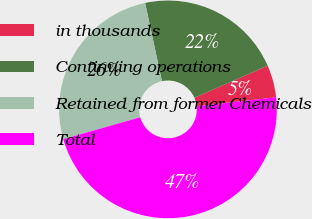<chart> <loc_0><loc_0><loc_500><loc_500><pie_chart><fcel>in thousands<fcel>Continuing operations<fcel>Retained from former Chemicals<fcel>Total<nl><fcel>4.81%<fcel>21.79%<fcel>26.05%<fcel>47.35%<nl></chart> 